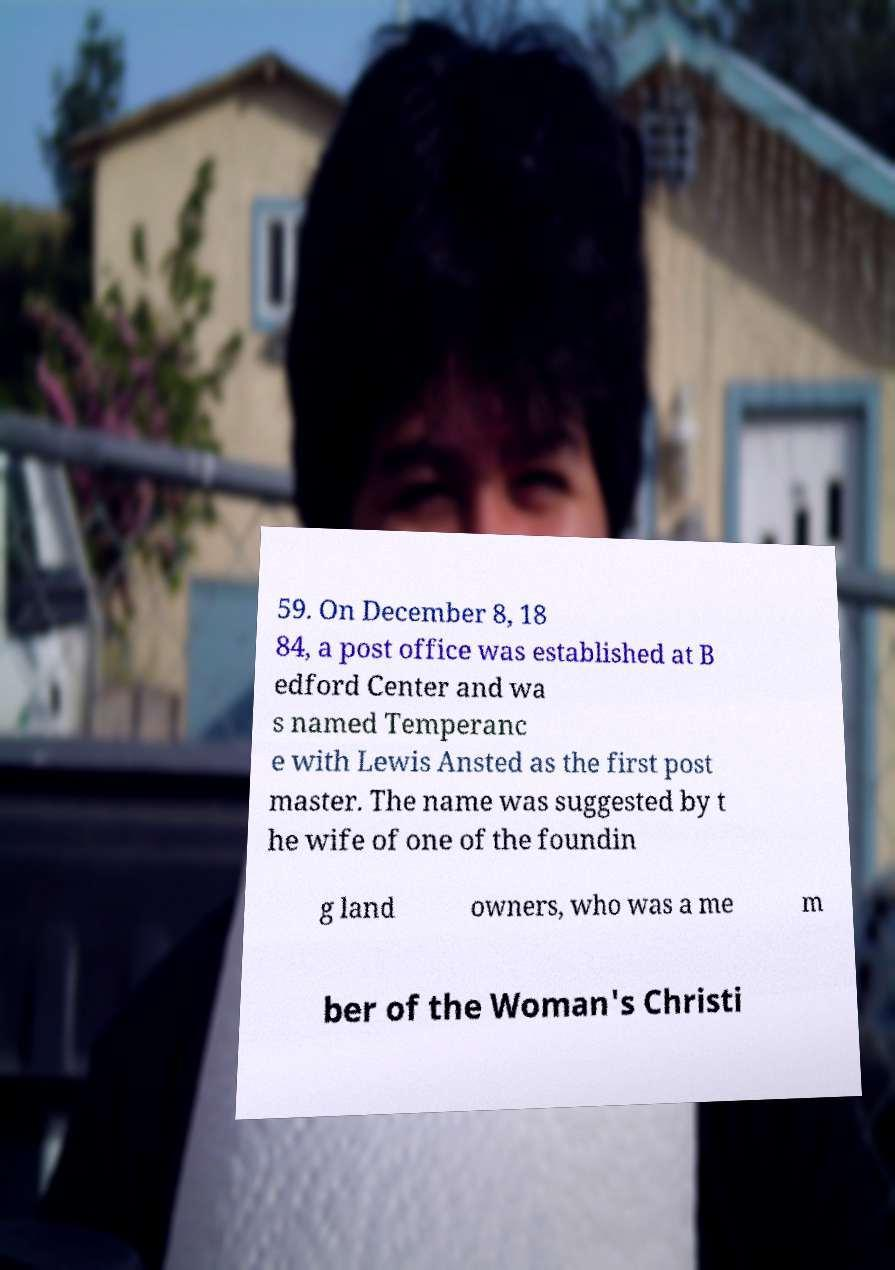What messages or text are displayed in this image? I need them in a readable, typed format. 59. On December 8, 18 84, a post office was established at B edford Center and wa s named Temperanc e with Lewis Ansted as the first post master. The name was suggested by t he wife of one of the foundin g land owners, who was a me m ber of the Woman's Christi 